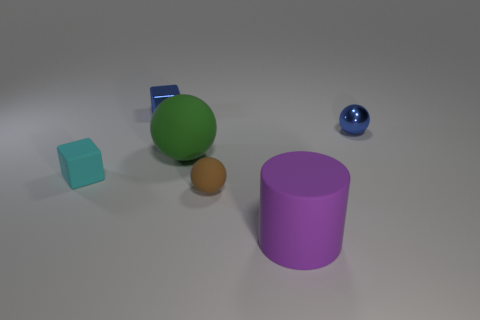The shiny object that is the same color as the small shiny cube is what size?
Your answer should be very brief. Small. Is there a sphere that has the same material as the cylinder?
Provide a short and direct response. Yes. There is a small block that is to the left of the blue shiny block; what is its material?
Offer a very short reply. Rubber. There is a big rubber thing that is behind the cylinder; is its color the same as the thing that is in front of the small brown object?
Keep it short and to the point. No. The rubber ball that is the same size as the purple thing is what color?
Offer a very short reply. Green. How many other things are there of the same shape as the cyan thing?
Offer a very short reply. 1. There is a matte ball in front of the tiny cyan rubber thing; what is its size?
Provide a short and direct response. Small. How many big rubber balls are on the right side of the ball in front of the tiny cyan rubber object?
Your answer should be compact. 0. What number of other things are there of the same size as the purple object?
Keep it short and to the point. 1. Is the color of the small metal sphere the same as the shiny block?
Ensure brevity in your answer.  Yes. 